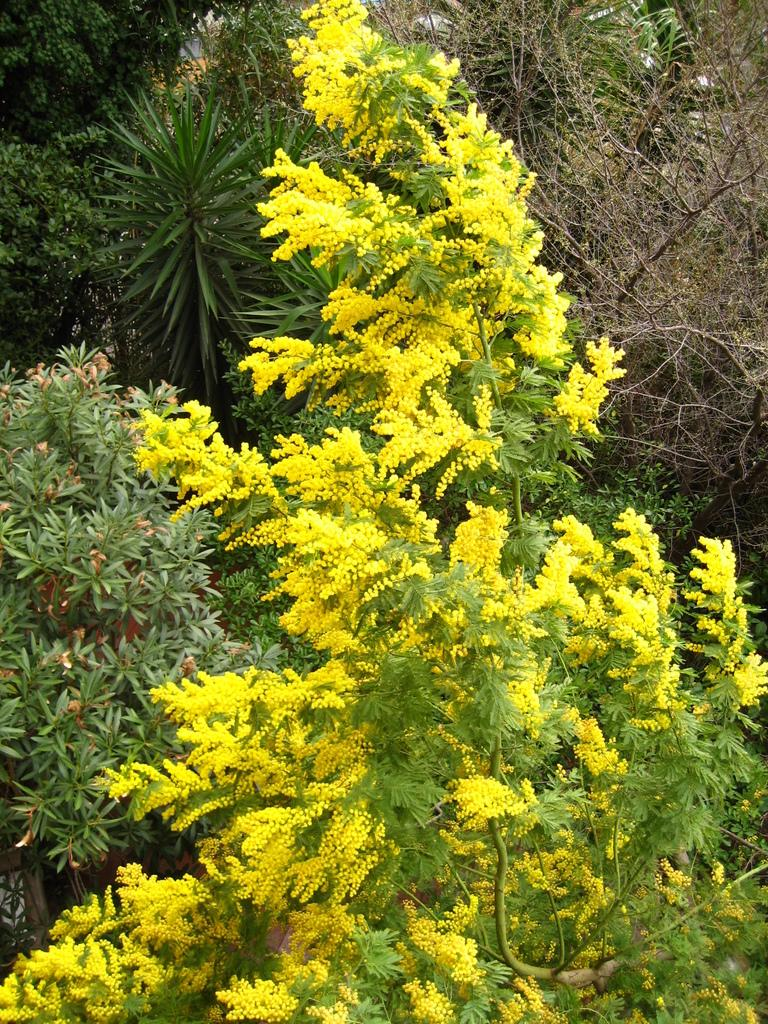What type of vegetation can be seen in the image? There are trees and flowers in the image. Can you describe the colors of the flowers? The colors of the flowers cannot be determined from the provided facts. Are there any other objects or features in the image besides the trees and flowers? No additional information is provided about other objects or features in the image. Are there any icicles hanging from the trees in the image? There is no mention of icicles in the provided facts, so it cannot be determined if they are present in the image. Is there a club visible in the image? There is no mention of a club in the provided facts, so it cannot be determined if it is present in the image. 